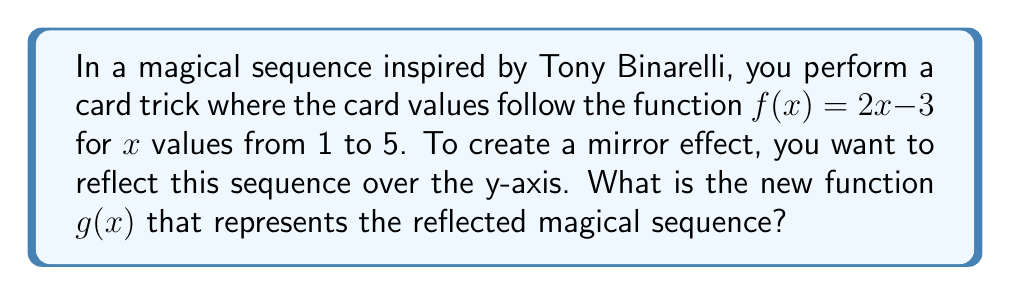Solve this math problem. To reflect a function over the y-axis, we need to follow these steps:

1) The general form for reflecting a function $f(x)$ over the y-axis is $g(x) = f(-x)$.

2) Our original function is $f(x) = 2x - 3$.

3) Replace all $x$ with $-x$ in the original function:
   $g(x) = 2(-x) - 3$

4) Simplify:
   $g(x) = -2x - 3$

5) Therefore, the new function $g(x)$ that represents the reflected magical sequence is $g(x) = -2x - 3$.

This reflection will create a mirror image of the original sequence, perfect for a magical mirror trick inspired by Tony Binarelli's style.
Answer: $g(x) = -2x - 3$ 